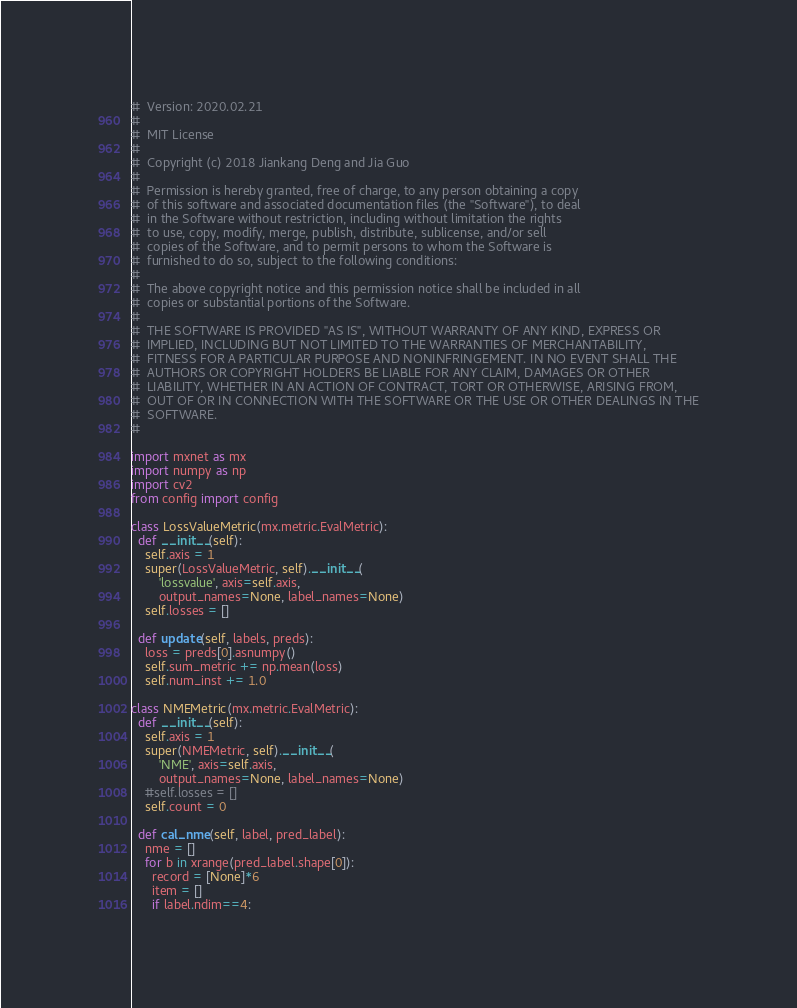<code> <loc_0><loc_0><loc_500><loc_500><_Python_>#  Version: 2020.02.21
#
#  MIT License
#
#  Copyright (c) 2018 Jiankang Deng and Jia Guo
#
#  Permission is hereby granted, free of charge, to any person obtaining a copy
#  of this software and associated documentation files (the "Software"), to deal
#  in the Software without restriction, including without limitation the rights
#  to use, copy, modify, merge, publish, distribute, sublicense, and/or sell
#  copies of the Software, and to permit persons to whom the Software is
#  furnished to do so, subject to the following conditions:
#
#  The above copyright notice and this permission notice shall be included in all
#  copies or substantial portions of the Software.
#
#  THE SOFTWARE IS PROVIDED "AS IS", WITHOUT WARRANTY OF ANY KIND, EXPRESS OR
#  IMPLIED, INCLUDING BUT NOT LIMITED TO THE WARRANTIES OF MERCHANTABILITY,
#  FITNESS FOR A PARTICULAR PURPOSE AND NONINFRINGEMENT. IN NO EVENT SHALL THE
#  AUTHORS OR COPYRIGHT HOLDERS BE LIABLE FOR ANY CLAIM, DAMAGES OR OTHER
#  LIABILITY, WHETHER IN AN ACTION OF CONTRACT, TORT OR OTHERWISE, ARISING FROM,
#  OUT OF OR IN CONNECTION WITH THE SOFTWARE OR THE USE OR OTHER DEALINGS IN THE
#  SOFTWARE.
#

import mxnet as mx
import numpy as np
import cv2
from config import config

class LossValueMetric(mx.metric.EvalMetric):
  def __init__(self):
    self.axis = 1
    super(LossValueMetric, self).__init__(
        'lossvalue', axis=self.axis,
        output_names=None, label_names=None)
    self.losses = []

  def update(self, labels, preds):
    loss = preds[0].asnumpy()
    self.sum_metric += np.mean(loss)
    self.num_inst += 1.0

class NMEMetric(mx.metric.EvalMetric):
  def __init__(self):
    self.axis = 1
    super(NMEMetric, self).__init__(
        'NME', axis=self.axis,
        output_names=None, label_names=None)
    #self.losses = []
    self.count = 0

  def cal_nme(self, label, pred_label):
    nme = []
    for b in xrange(pred_label.shape[0]):
      record = [None]*6
      item = []
      if label.ndim==4:</code> 